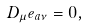<formula> <loc_0><loc_0><loc_500><loc_500>D _ { \mu } e _ { a \nu } = 0 ,</formula> 